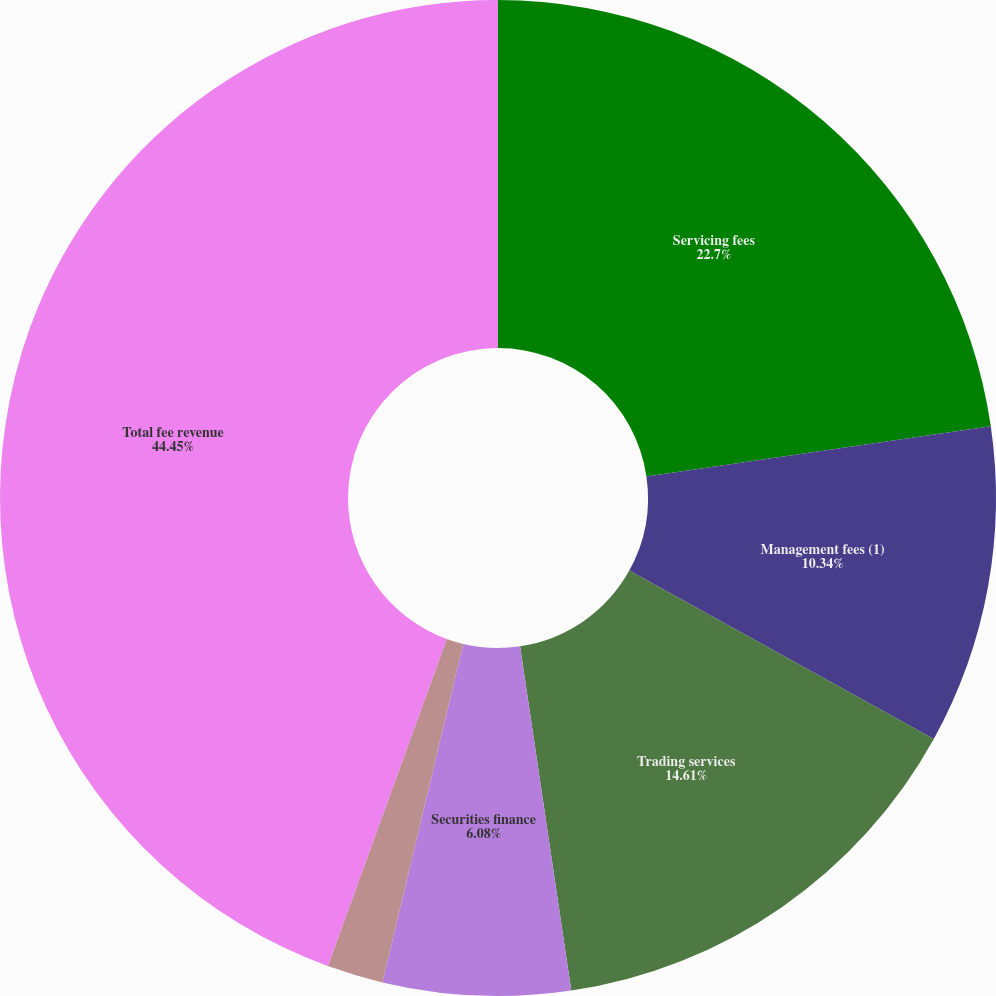Convert chart to OTSL. <chart><loc_0><loc_0><loc_500><loc_500><pie_chart><fcel>Servicing fees<fcel>Management fees (1)<fcel>Trading services<fcel>Securities finance<fcel>Processing fees and other<fcel>Total fee revenue<nl><fcel>22.7%<fcel>10.34%<fcel>14.61%<fcel>6.08%<fcel>1.82%<fcel>44.45%<nl></chart> 